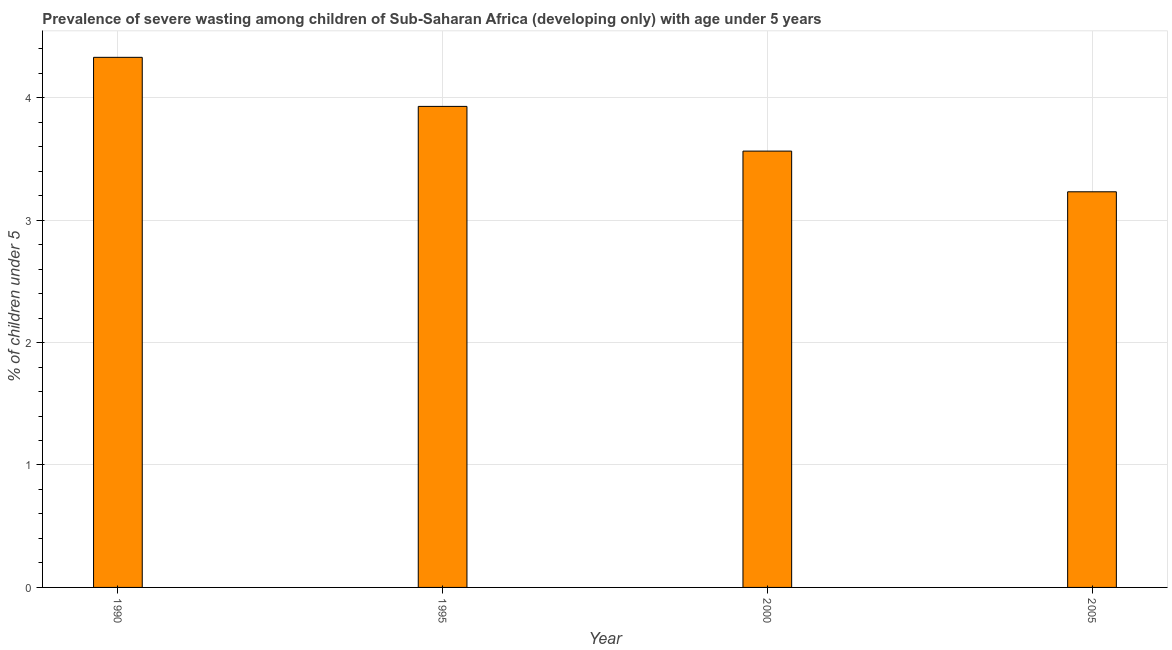Does the graph contain any zero values?
Ensure brevity in your answer.  No. What is the title of the graph?
Give a very brief answer. Prevalence of severe wasting among children of Sub-Saharan Africa (developing only) with age under 5 years. What is the label or title of the Y-axis?
Offer a terse response.  % of children under 5. What is the prevalence of severe wasting in 1995?
Make the answer very short. 3.93. Across all years, what is the maximum prevalence of severe wasting?
Your response must be concise. 4.33. Across all years, what is the minimum prevalence of severe wasting?
Give a very brief answer. 3.23. In which year was the prevalence of severe wasting maximum?
Offer a terse response. 1990. What is the sum of the prevalence of severe wasting?
Give a very brief answer. 15.05. What is the difference between the prevalence of severe wasting in 1990 and 1995?
Make the answer very short. 0.4. What is the average prevalence of severe wasting per year?
Ensure brevity in your answer.  3.76. What is the median prevalence of severe wasting?
Provide a succinct answer. 3.75. In how many years, is the prevalence of severe wasting greater than 2 %?
Offer a terse response. 4. Do a majority of the years between 2000 and 1995 (inclusive) have prevalence of severe wasting greater than 2.2 %?
Offer a very short reply. No. What is the ratio of the prevalence of severe wasting in 1995 to that in 2000?
Ensure brevity in your answer.  1.1. Is the prevalence of severe wasting in 1995 less than that in 2005?
Offer a very short reply. No. Is the difference between the prevalence of severe wasting in 1990 and 2000 greater than the difference between any two years?
Keep it short and to the point. No. What is the difference between the highest and the second highest prevalence of severe wasting?
Your answer should be very brief. 0.4. Is the sum of the prevalence of severe wasting in 1995 and 2000 greater than the maximum prevalence of severe wasting across all years?
Your answer should be very brief. Yes. What is the  % of children under 5 of 1990?
Provide a succinct answer. 4.33. What is the  % of children under 5 of 1995?
Give a very brief answer. 3.93. What is the  % of children under 5 in 2000?
Keep it short and to the point. 3.56. What is the  % of children under 5 in 2005?
Your answer should be very brief. 3.23. What is the difference between the  % of children under 5 in 1990 and 1995?
Keep it short and to the point. 0.4. What is the difference between the  % of children under 5 in 1990 and 2000?
Your answer should be very brief. 0.77. What is the difference between the  % of children under 5 in 1990 and 2005?
Offer a very short reply. 1.1. What is the difference between the  % of children under 5 in 1995 and 2000?
Provide a succinct answer. 0.37. What is the difference between the  % of children under 5 in 1995 and 2005?
Provide a short and direct response. 0.7. What is the difference between the  % of children under 5 in 2000 and 2005?
Ensure brevity in your answer.  0.33. What is the ratio of the  % of children under 5 in 1990 to that in 1995?
Your answer should be very brief. 1.1. What is the ratio of the  % of children under 5 in 1990 to that in 2000?
Your answer should be compact. 1.22. What is the ratio of the  % of children under 5 in 1990 to that in 2005?
Your answer should be compact. 1.34. What is the ratio of the  % of children under 5 in 1995 to that in 2000?
Provide a short and direct response. 1.1. What is the ratio of the  % of children under 5 in 1995 to that in 2005?
Give a very brief answer. 1.22. What is the ratio of the  % of children under 5 in 2000 to that in 2005?
Your answer should be very brief. 1.1. 